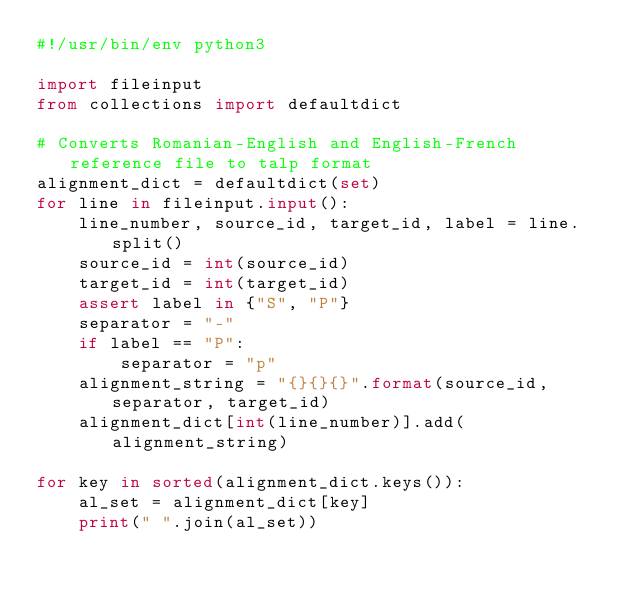Convert code to text. <code><loc_0><loc_0><loc_500><loc_500><_Python_>#!/usr/bin/env python3

import fileinput
from collections import defaultdict

# Converts Romanian-English and English-French reference file to talp format
alignment_dict = defaultdict(set)
for line in fileinput.input():
    line_number, source_id, target_id, label = line.split()
    source_id = int(source_id)
    target_id = int(target_id)
    assert label in {"S", "P"}
    separator = "-"
    if label == "P":
        separator = "p"
    alignment_string = "{}{}{}".format(source_id, separator, target_id)
    alignment_dict[int(line_number)].add(alignment_string)

for key in sorted(alignment_dict.keys()):
    al_set = alignment_dict[key]
    print(" ".join(al_set))

</code> 